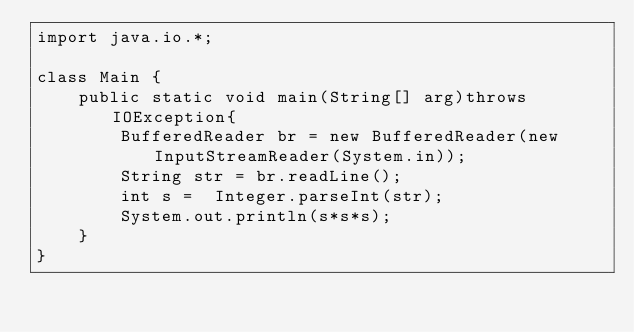<code> <loc_0><loc_0><loc_500><loc_500><_Java_>import java.io.*;
 
class Main {
    public static void main(String[] arg)throws IOException{
        BufferedReader br = new BufferedReader(new InputStreamReader(System.in));
        String str = br.readLine();
        int s =  Integer.parseInt(str);
        System.out.println(s*s*s);
    }   
}</code> 